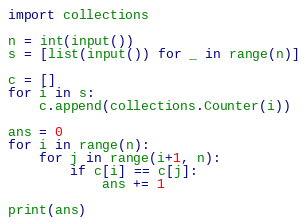Convert code to text. <code><loc_0><loc_0><loc_500><loc_500><_Python_>import collections

n = int(input())
s = [list(input()) for _ in range(n)]

c = []
for i in s:
    c.append(collections.Counter(i))

ans = 0
for i in range(n):
    for j in range(i+1, n):
        if c[i] == c[j]:
            ans += 1
            
print(ans)</code> 